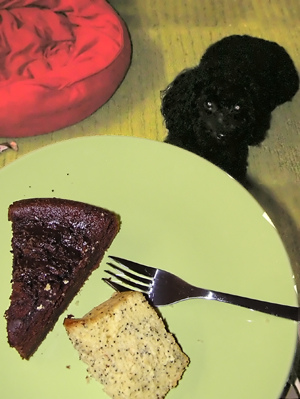<image>
Is the cake on the cake? No. The cake is not positioned on the cake. They may be near each other, but the cake is not supported by or resting on top of the cake. Is the dog under the chocolate? Yes. The dog is positioned underneath the chocolate, with the chocolate above it in the vertical space. 